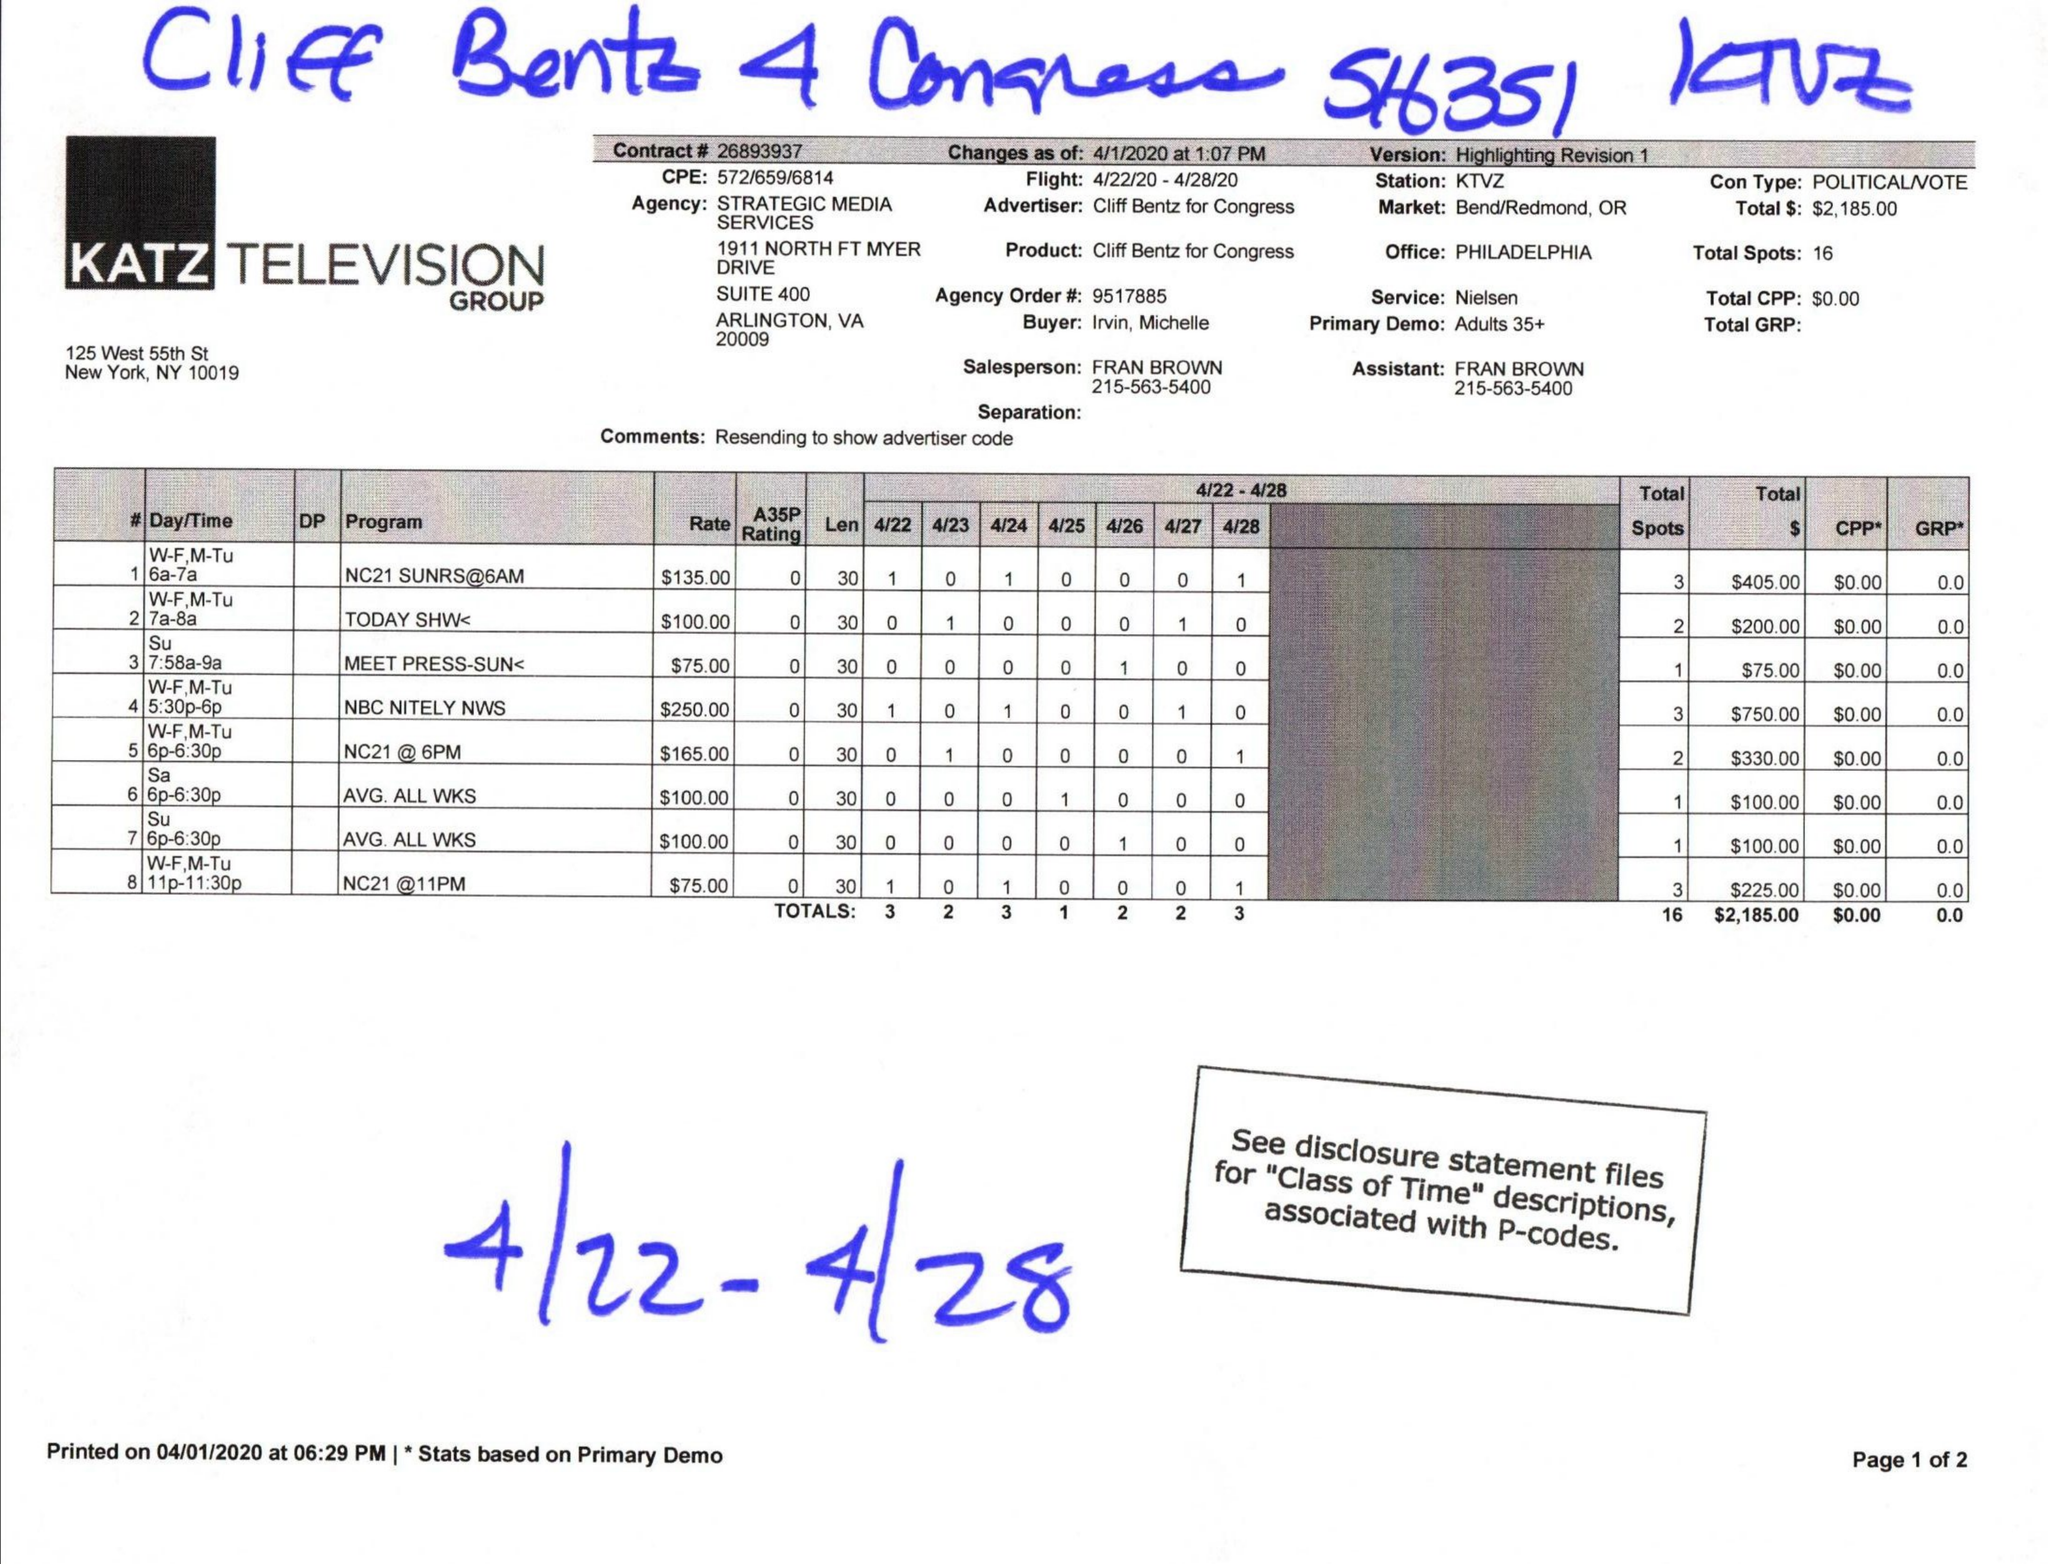What is the value for the contract_num?
Answer the question using a single word or phrase. 26893937 